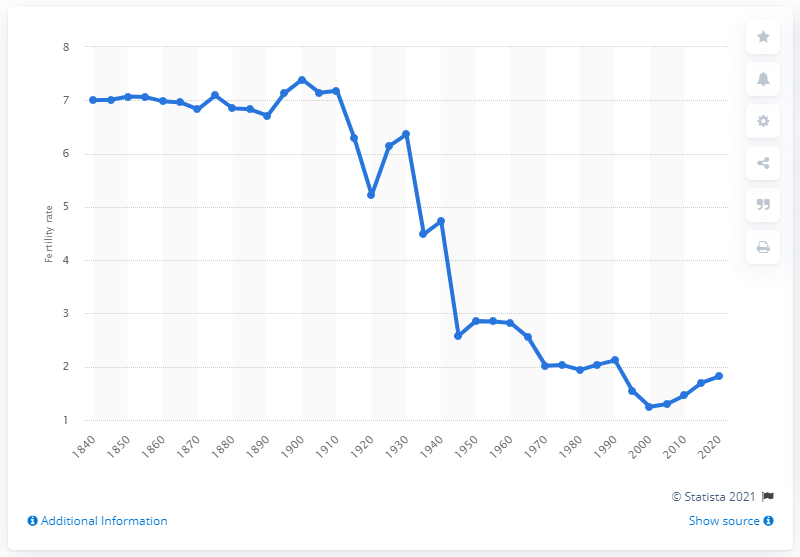Indicate a few pertinent items in this graphic. According to data from 2000, Russia's fertility rate was 1.25. 